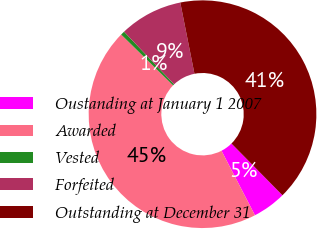Convert chart. <chart><loc_0><loc_0><loc_500><loc_500><pie_chart><fcel>Oustanding at January 1 2007<fcel>Awarded<fcel>Vested<fcel>Forfeited<fcel>Outstanding at December 31<nl><fcel>4.77%<fcel>44.94%<fcel>0.57%<fcel>8.97%<fcel>40.74%<nl></chart> 